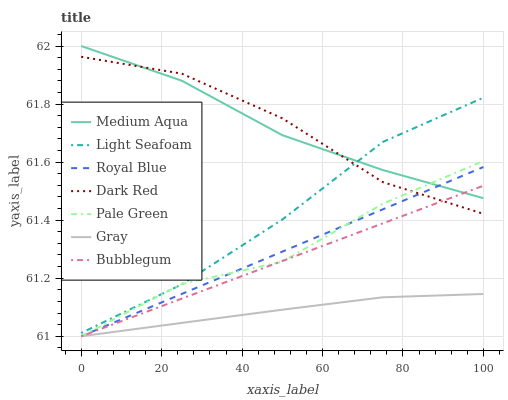Does Gray have the minimum area under the curve?
Answer yes or no. Yes. Does Medium Aqua have the maximum area under the curve?
Answer yes or no. Yes. Does Dark Red have the minimum area under the curve?
Answer yes or no. No. Does Dark Red have the maximum area under the curve?
Answer yes or no. No. Is Bubblegum the smoothest?
Answer yes or no. Yes. Is Pale Green the roughest?
Answer yes or no. Yes. Is Dark Red the smoothest?
Answer yes or no. No. Is Dark Red the roughest?
Answer yes or no. No. Does Gray have the lowest value?
Answer yes or no. Yes. Does Dark Red have the lowest value?
Answer yes or no. No. Does Medium Aqua have the highest value?
Answer yes or no. Yes. Does Dark Red have the highest value?
Answer yes or no. No. Is Royal Blue less than Light Seafoam?
Answer yes or no. Yes. Is Light Seafoam greater than Gray?
Answer yes or no. Yes. Does Royal Blue intersect Pale Green?
Answer yes or no. Yes. Is Royal Blue less than Pale Green?
Answer yes or no. No. Is Royal Blue greater than Pale Green?
Answer yes or no. No. Does Royal Blue intersect Light Seafoam?
Answer yes or no. No. 